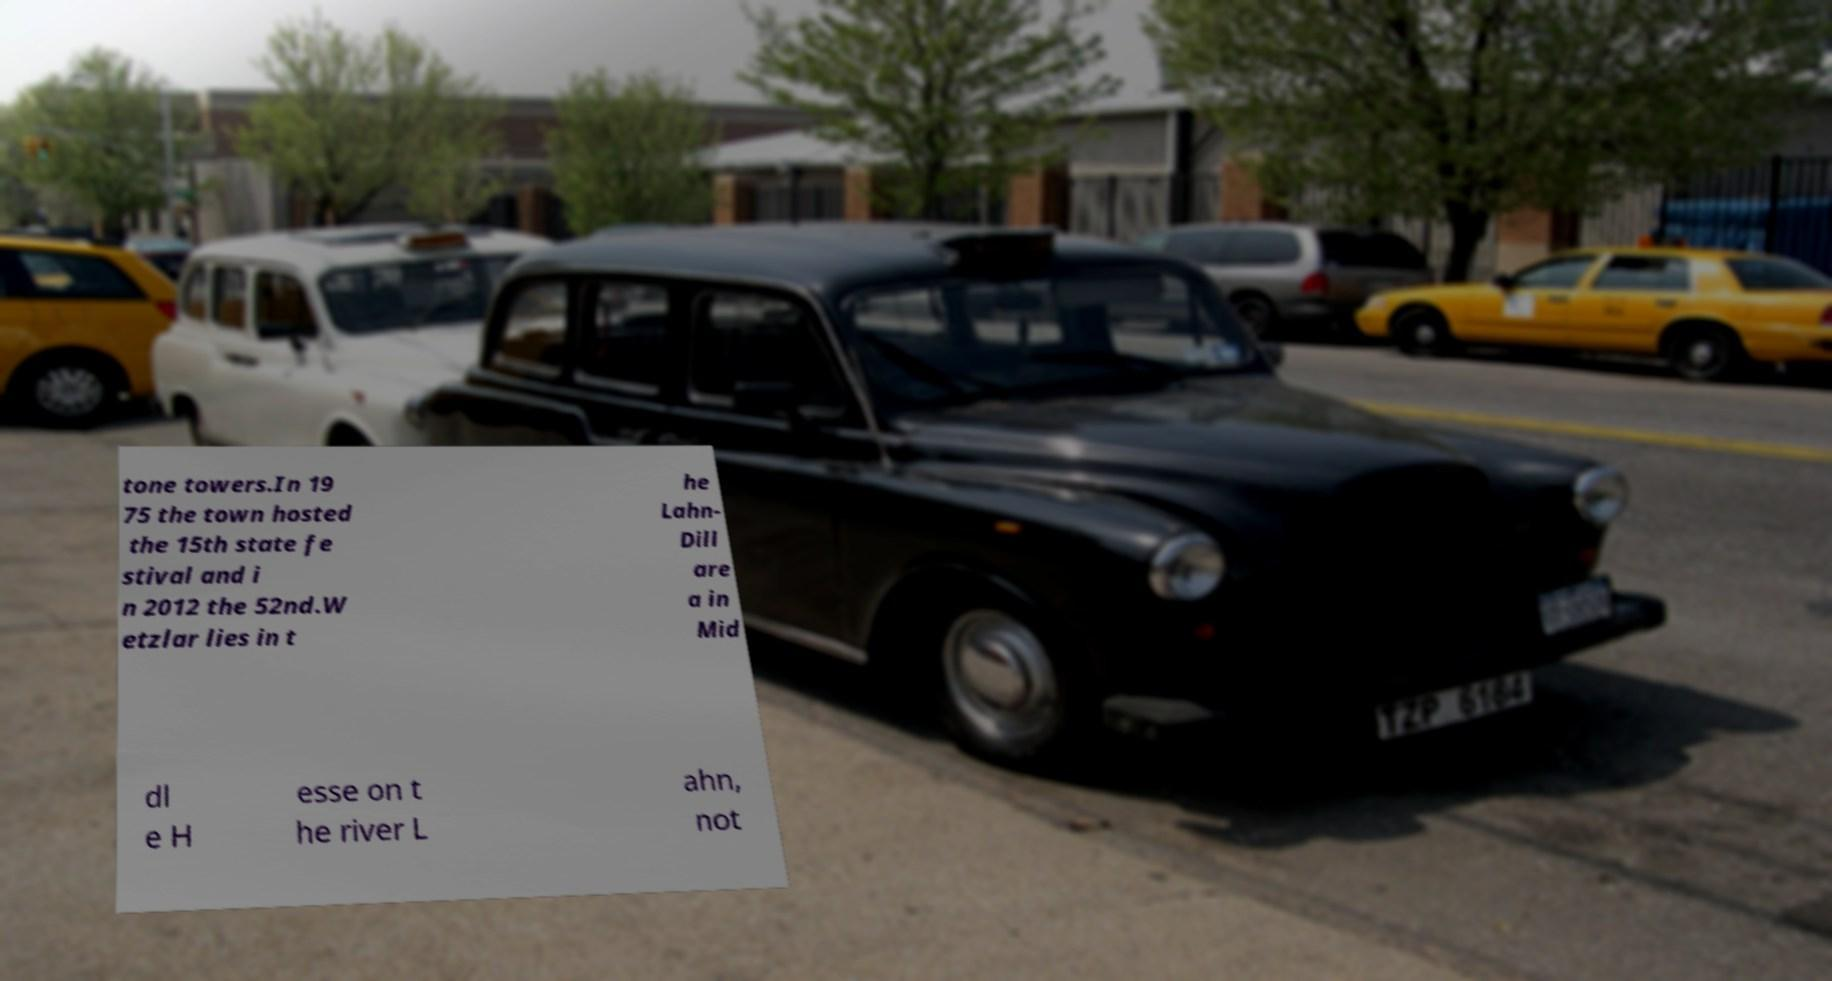There's text embedded in this image that I need extracted. Can you transcribe it verbatim? tone towers.In 19 75 the town hosted the 15th state fe stival and i n 2012 the 52nd.W etzlar lies in t he Lahn- Dill are a in Mid dl e H esse on t he river L ahn, not 